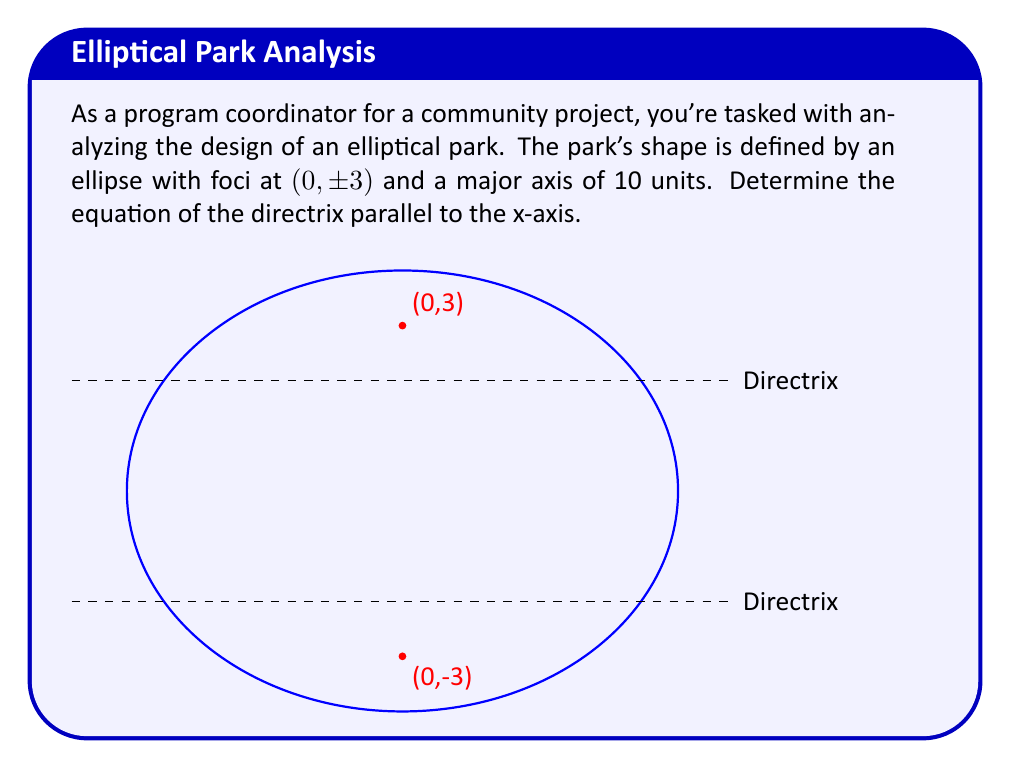Teach me how to tackle this problem. Let's approach this step-by-step:

1) For an ellipse, the equation of the directrix is given by $y = \pm \frac{a}{e}$, where $a$ is the length of the semi-major axis and $e$ is the eccentricity.

2) We're given that the major axis is 10 units, so $a = 5$.

3) To find the eccentricity, we need the distance from the center to a focus, which is 3 (given as (0, ±3)).

4) The eccentricity is defined as $e = \frac{c}{a}$, where $c$ is the distance from the center to a focus.

   $e = \frac{3}{5}$

5) Now we can substitute into the directrix equation:

   $y = \pm \frac{a}{e} = \pm \frac{5}{\frac{3}{5}} = \pm \frac{25}{3}$

6) Therefore, the equations of the directrices are:

   $y = \frac{25}{3}$ and $y = -\frac{25}{3}$
Answer: $y = \pm \frac{25}{3}$ 